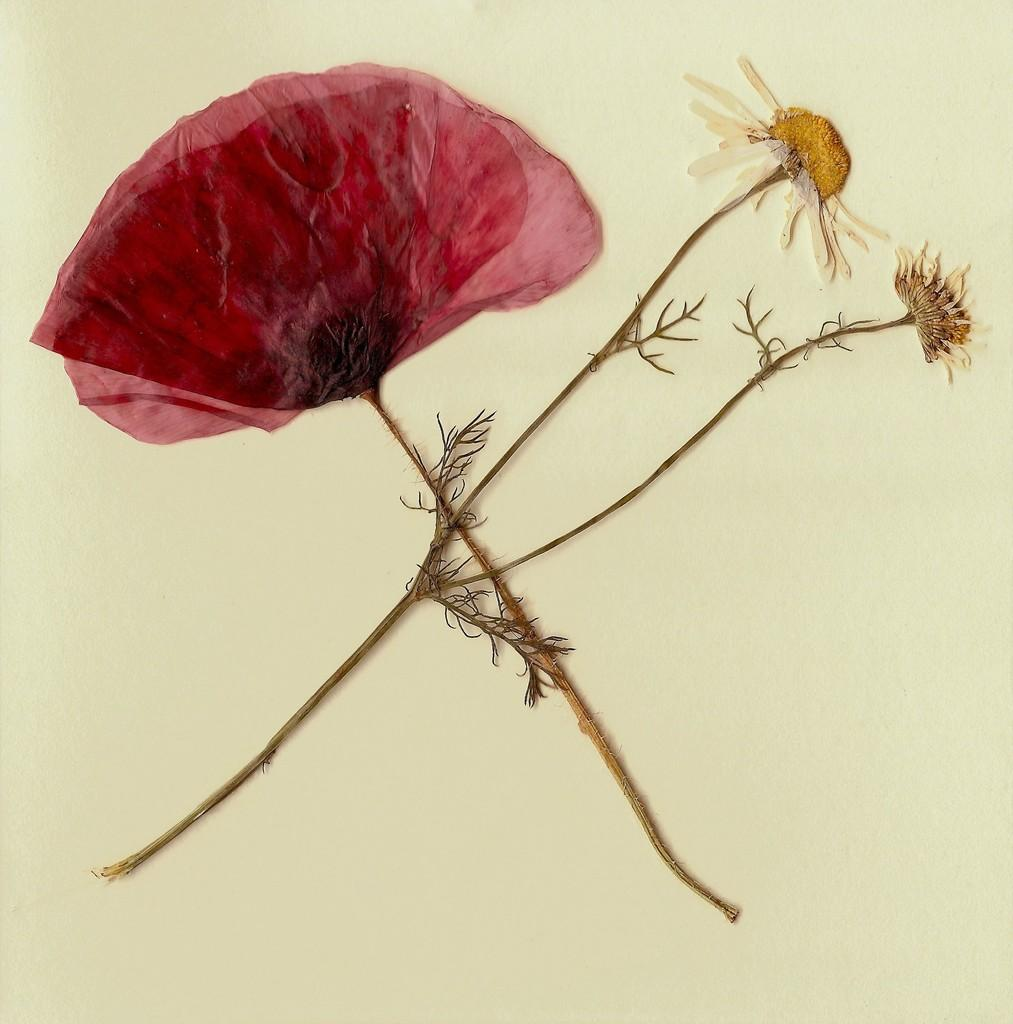What is the main subject of the image? The main subject of the image is a flower. Where is the flower located in the image? The flower is on the wall in the image. Can you describe the position of the flower in the image? The flower is in the center of the image. How many pages of the book does the flower turn in the image? There is no book or page turning in the image; it only features a flower on the wall. 